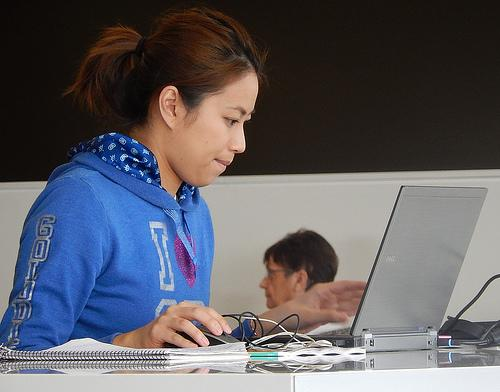In a passive voice, explain what the woman wearing a blue hoodie with a heart is doing. A laptop is being used by the woman wearing a blue hoodie with a heart, who also has her hand on a computer mouse. Identify what the woman in the blue sweatshirt is using and what is on the table. The woman in the blue sweatshirt is using a laptop and there is a spiral notebook and a computer mouse on the table. Capture the essence of the image by emphasizing the woman's attire and her current task. A woman donning a blue sweatshirt with a pink heart design is focusing on her laptop, using a mouse while she works. Summarize the scene depicted in the image briefly. A woman in a blue sweatshirt with a heart design is working on a laptop on a white table, with a notebook and a mouse nearby, while another person is visible in the background. Mention what the woman is doing, including the objects she is interacting with on the table. The woman is working on a laptop, using a computer mouse, and has a spiral notebook open on the table. Describe the image focusing on the woman's appearance as well as her activities. A woman with brown hair in a ponytail, wearing a blue hooded sweatshirt featuring a pink heart design, is engaged in working on her laptop while holding a computer mouse. Mention what the woman in the foreground is wearing and doing. The woman in the foreground is wearing a blue hoodie with a pink heart and working on a laptop with her hand on a mouse. List the main elements of the image focusing on the woman, her outfit, and her actions. Woman, blue sweatshirt with heart design, ponytail, working on laptop, holding computer mouse. Using descriptive verbs, convey the main action of the woman in the image. A woman in a heart-adorned blue hoodie is intently working on her laptop, maneuvering the mouse as she goes. Describe the setting of the image, including the items around the main subject. The setting is an indoor space with a woman at a white table working on a laptop, a spiral notebook and a computer mouse beside her, wires near the laptop, and a person in the background. 